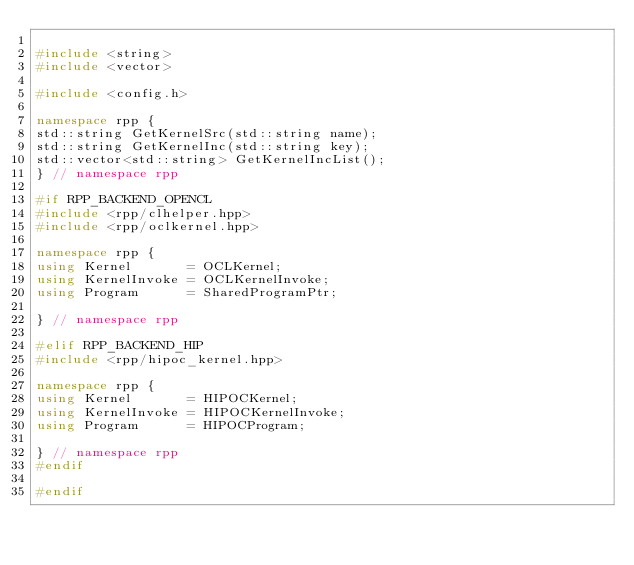<code> <loc_0><loc_0><loc_500><loc_500><_C++_>
#include <string>
#include <vector>

#include <config.h>

namespace rpp {
std::string GetKernelSrc(std::string name);
std::string GetKernelInc(std::string key);
std::vector<std::string> GetKernelIncList();
} // namespace rpp

#if RPP_BACKEND_OPENCL
#include <rpp/clhelper.hpp>
#include <rpp/oclkernel.hpp>

namespace rpp {
using Kernel       = OCLKernel;
using KernelInvoke = OCLKernelInvoke;
using Program      = SharedProgramPtr;

} // namespace rpp

#elif RPP_BACKEND_HIP
#include <rpp/hipoc_kernel.hpp>

namespace rpp {
using Kernel       = HIPOCKernel;
using KernelInvoke = HIPOCKernelInvoke;
using Program      = HIPOCProgram;

} // namespace rpp
#endif

#endif
</code> 